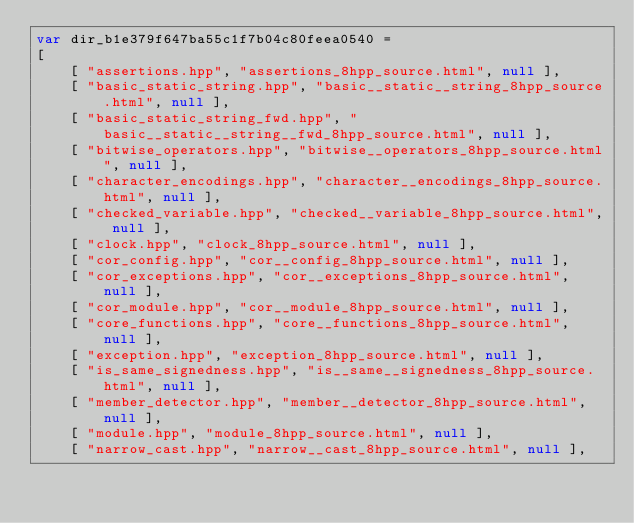<code> <loc_0><loc_0><loc_500><loc_500><_JavaScript_>var dir_b1e379f647ba55c1f7b04c80feea0540 =
[
    [ "assertions.hpp", "assertions_8hpp_source.html", null ],
    [ "basic_static_string.hpp", "basic__static__string_8hpp_source.html", null ],
    [ "basic_static_string_fwd.hpp", "basic__static__string__fwd_8hpp_source.html", null ],
    [ "bitwise_operators.hpp", "bitwise__operators_8hpp_source.html", null ],
    [ "character_encodings.hpp", "character__encodings_8hpp_source.html", null ],
    [ "checked_variable.hpp", "checked__variable_8hpp_source.html", null ],
    [ "clock.hpp", "clock_8hpp_source.html", null ],
    [ "cor_config.hpp", "cor__config_8hpp_source.html", null ],
    [ "cor_exceptions.hpp", "cor__exceptions_8hpp_source.html", null ],
    [ "cor_module.hpp", "cor__module_8hpp_source.html", null ],
    [ "core_functions.hpp", "core__functions_8hpp_source.html", null ],
    [ "exception.hpp", "exception_8hpp_source.html", null ],
    [ "is_same_signedness.hpp", "is__same__signedness_8hpp_source.html", null ],
    [ "member_detector.hpp", "member__detector_8hpp_source.html", null ],
    [ "module.hpp", "module_8hpp_source.html", null ],
    [ "narrow_cast.hpp", "narrow__cast_8hpp_source.html", null ],</code> 